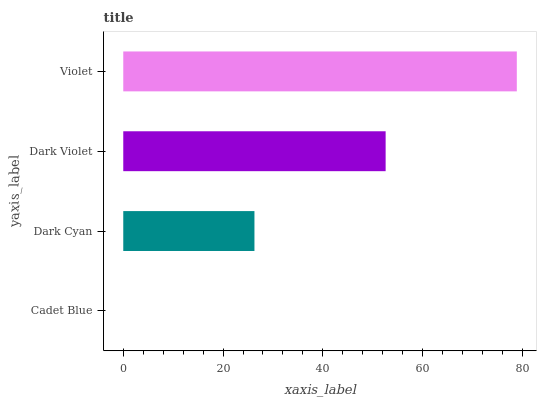Is Cadet Blue the minimum?
Answer yes or no. Yes. Is Violet the maximum?
Answer yes or no. Yes. Is Dark Cyan the minimum?
Answer yes or no. No. Is Dark Cyan the maximum?
Answer yes or no. No. Is Dark Cyan greater than Cadet Blue?
Answer yes or no. Yes. Is Cadet Blue less than Dark Cyan?
Answer yes or no. Yes. Is Cadet Blue greater than Dark Cyan?
Answer yes or no. No. Is Dark Cyan less than Cadet Blue?
Answer yes or no. No. Is Dark Violet the high median?
Answer yes or no. Yes. Is Dark Cyan the low median?
Answer yes or no. Yes. Is Dark Cyan the high median?
Answer yes or no. No. Is Dark Violet the low median?
Answer yes or no. No. 